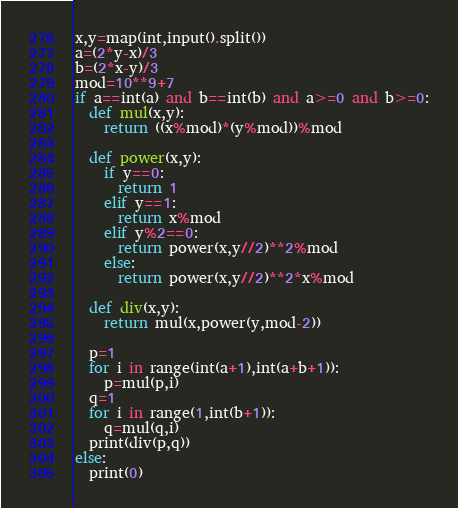<code> <loc_0><loc_0><loc_500><loc_500><_Python_>x,y=map(int,input().split())
a=(2*y-x)/3
b=(2*x-y)/3
mod=10**9+7
if a==int(a) and b==int(b) and a>=0 and b>=0:
  def mul(x,y):
    return ((x%mod)*(y%mod))%mod
  
  def power(x,y):
    if y==0:
      return 1
    elif y==1:
      return x%mod
    elif y%2==0:
      return power(x,y//2)**2%mod
    else:
      return power(x,y//2)**2*x%mod
    
  def div(x,y):
    return mul(x,power(y,mod-2))
  
  p=1
  for i in range(int(a+1),int(a+b+1)):
    p=mul(p,i)
  q=1
  for i in range(1,int(b+1)):
    q=mul(q,i)
  print(div(p,q))
else:
  print(0)</code> 